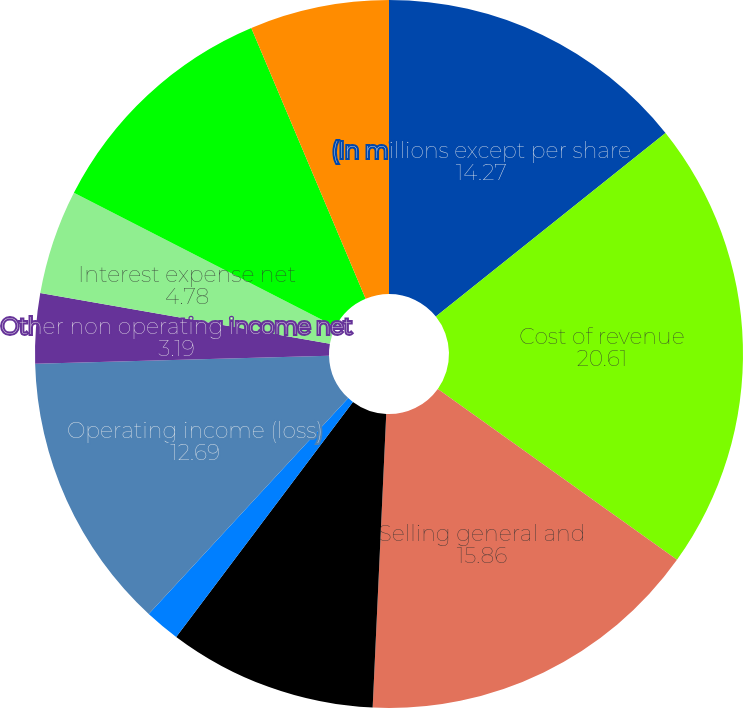Convert chart to OTSL. <chart><loc_0><loc_0><loc_500><loc_500><pie_chart><fcel>(In millions except per share<fcel>Cost of revenue<fcel>Selling general and<fcel>Restructuring impairment and<fcel>Merger and related costs (4)<fcel>Operating income (loss)<fcel>Other non operating income net<fcel>Interest expense net<fcel>Income (loss) before income<fcel>Income tax provision<nl><fcel>14.27%<fcel>20.61%<fcel>15.86%<fcel>9.53%<fcel>1.61%<fcel>12.69%<fcel>3.19%<fcel>4.78%<fcel>11.11%<fcel>6.36%<nl></chart> 